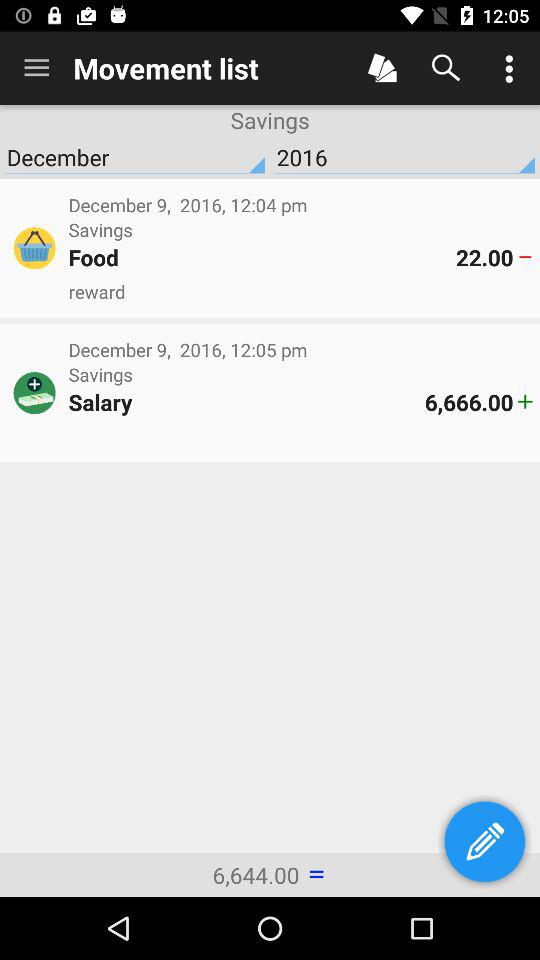How much was spent on food from the savings account? The amount spent on food is 22. 